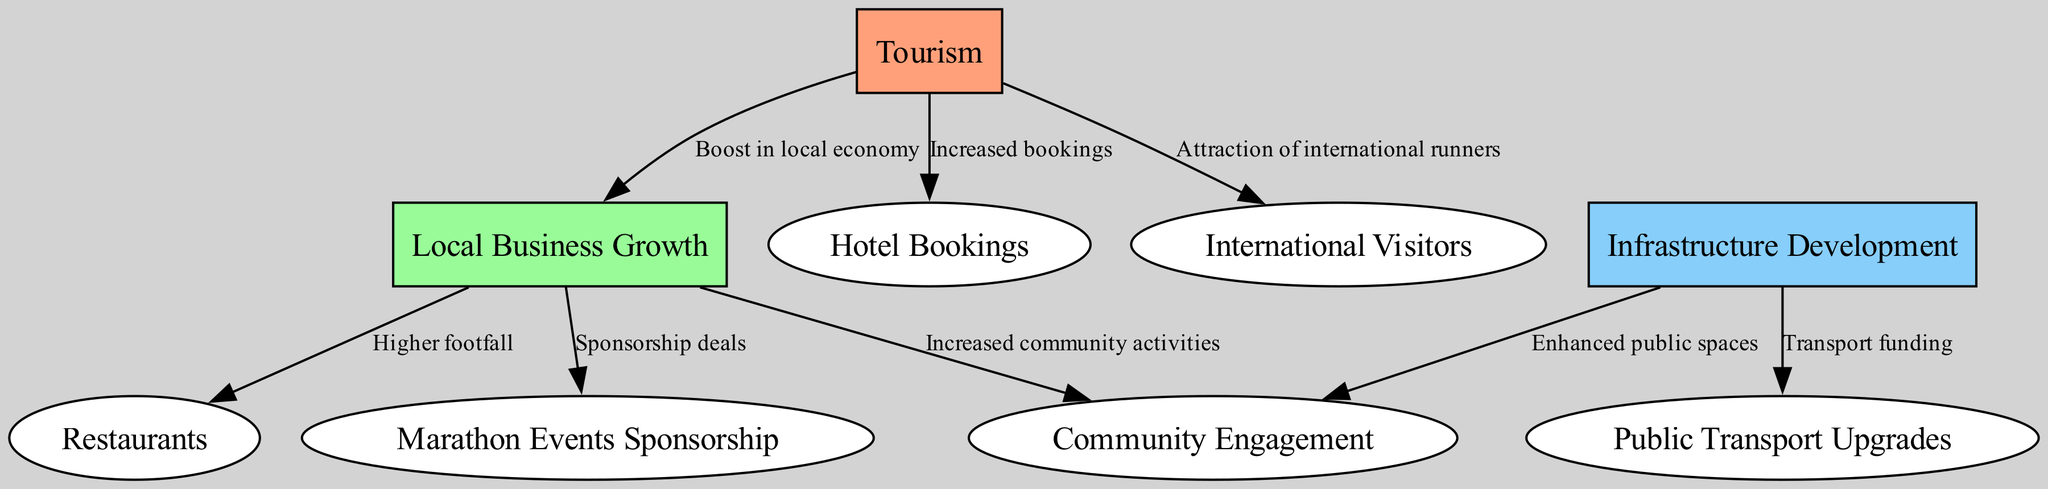What is the total number of nodes in the diagram? The diagram lists 9 unique nodes: Tourism, Local Business Growth, Infrastructure Development, Hotel Bookings, Restaurants, Public Transport Upgrades, International Visitors, Marathon Events Sponsorship, and Community Engagement. Counting these gives a total of 9 nodes.
Answer: 9 Which node represents the relationship that boosts the local economy? The edge connecting Tourism to Local Business Growth indicates that Tourism results in a boost for the local economy. Therefore, Local Business Growth is the node that represents this relationship.
Answer: Local Business Growth How many edges are connected to the Infrastructure Development node? The Infrastructure Development node has 2 outgoing edges: one to Public Transport Upgrades and another to Community Engagement. Thus, there are 2 edges connected to Infrastructure Development.
Answer: 2 What effect does Local Business Growth have on Restaurants? The diagram shows that Local Business Growth leads to Higher footfall at Restaurants. Thus, the effect of Local Business Growth on Restaurants is an increase in customer traffic.
Answer: Higher footfall What type of nodes are all the nodes connected to Tourism? The nodes connected to Tourism are Hotel Bookings, International Visitors, Local Business Growth. Since these nodes represent various aspects impacted by Tourism, they are categorized as secondary outcomes resulting from Tourism.
Answer: Secondary outcomes What is the relationship between Local Business Growth and Community Engagement? The edge from Local Business Growth to Community Engagement indicates that Local Business Growth leads to Increased community activities. This shows that as local businesses grow, communities become more engaged.
Answer: Increased community activities How does Infrastructure Development affect Public Transport Upgrades? The direct edge from Infrastructure Development to Public Transport Upgrades shows that improved funding for infrastructure projects directly contributes to upgrades in public transportation systems. Thus, Infrastructure Development affects Public Transport Upgrades through funding.
Answer: Transport funding How do Marathon Events influence Local Business Growth? The flow indicates that the boost in local economy from Tourism enhances Local Business Growth. Therefore, Marathon Events, by attracting tourism, subsequently foster growth among local businesses.
Answer: Boost in local economy Which node indicates the attraction of international runners? The connection from Tourism to International Visitors illustrates that an increase in tourism, particularly from marathon events, attracts international runners to the destination.
Answer: Attraction of international runners 